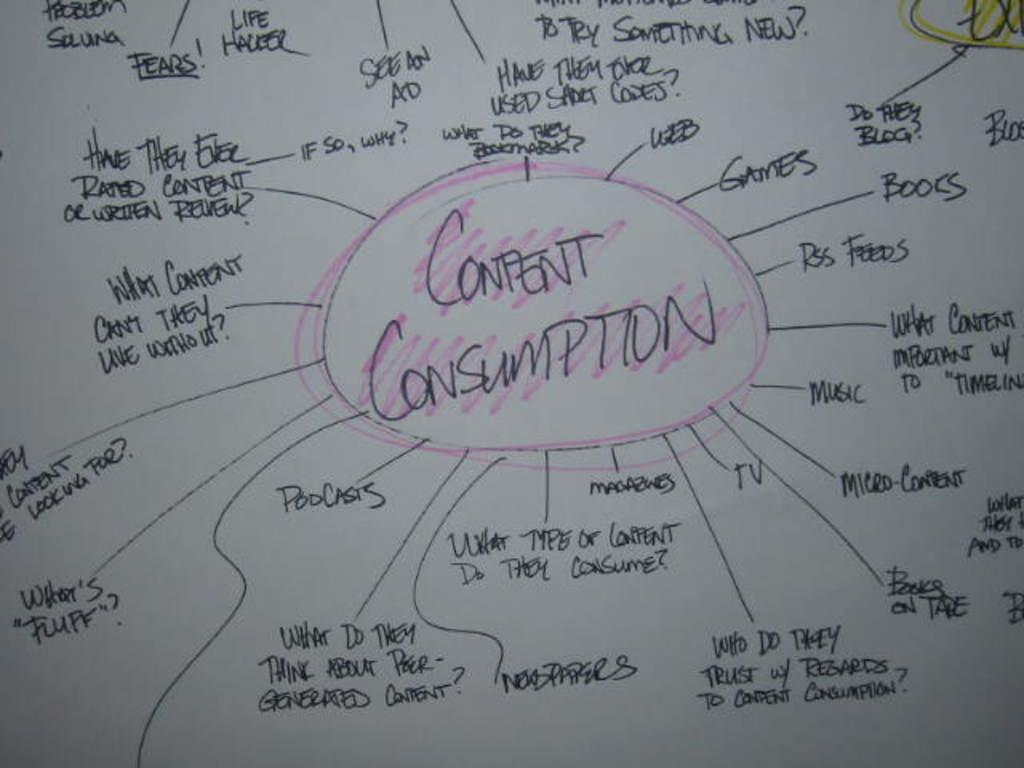<image>
Create a compact narrative representing the image presented. A white board that has a bubble chart on it that says Confent Consumption 